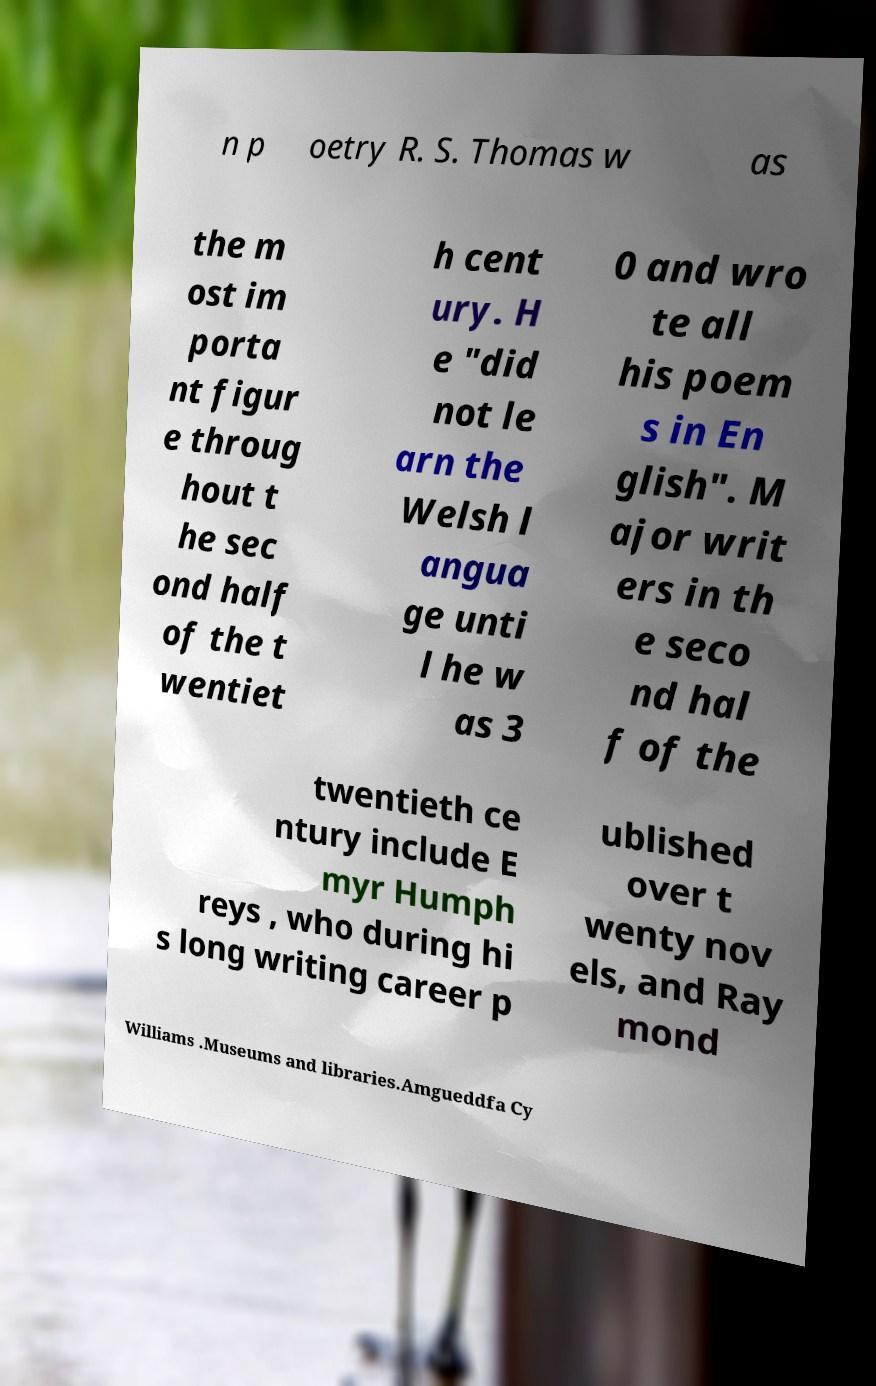What messages or text are displayed in this image? I need them in a readable, typed format. n p oetry R. S. Thomas w as the m ost im porta nt figur e throug hout t he sec ond half of the t wentiet h cent ury. H e "did not le arn the Welsh l angua ge unti l he w as 3 0 and wro te all his poem s in En glish". M ajor writ ers in th e seco nd hal f of the twentieth ce ntury include E myr Humph reys , who during hi s long writing career p ublished over t wenty nov els, and Ray mond Williams .Museums and libraries.Amgueddfa Cy 